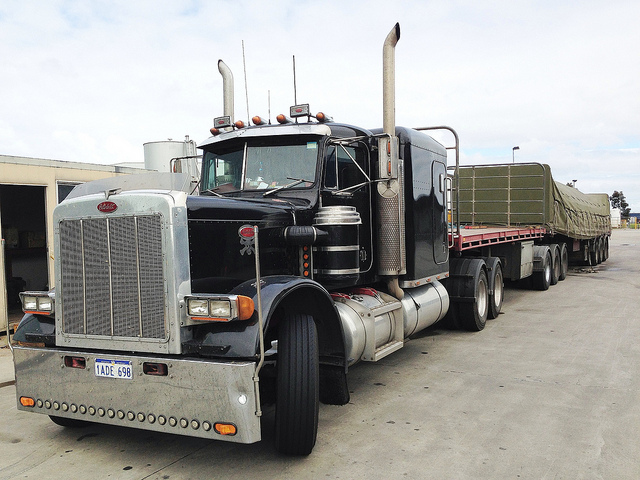Read and extract the text from this image. 1 ADE 698 